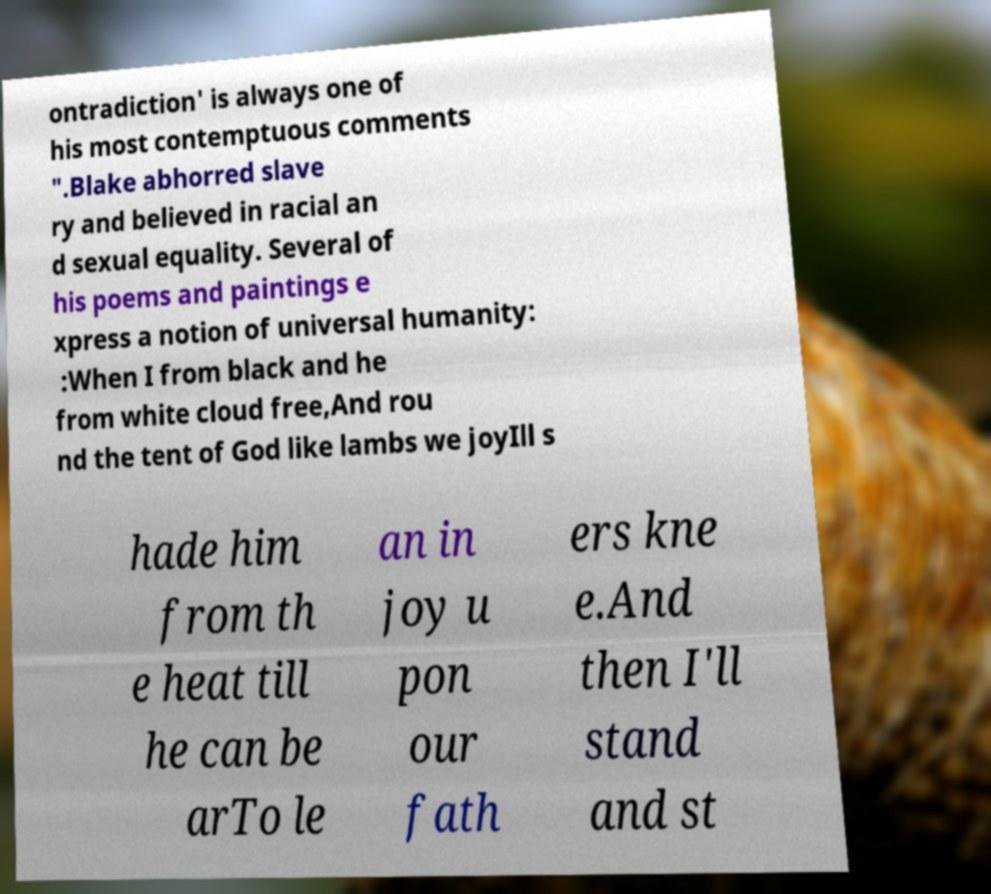Could you extract and type out the text from this image? ontradiction' is always one of his most contemptuous comments ".Blake abhorred slave ry and believed in racial an d sexual equality. Several of his poems and paintings e xpress a notion of universal humanity: :When I from black and he from white cloud free,And rou nd the tent of God like lambs we joyIll s hade him from th e heat till he can be arTo le an in joy u pon our fath ers kne e.And then I'll stand and st 